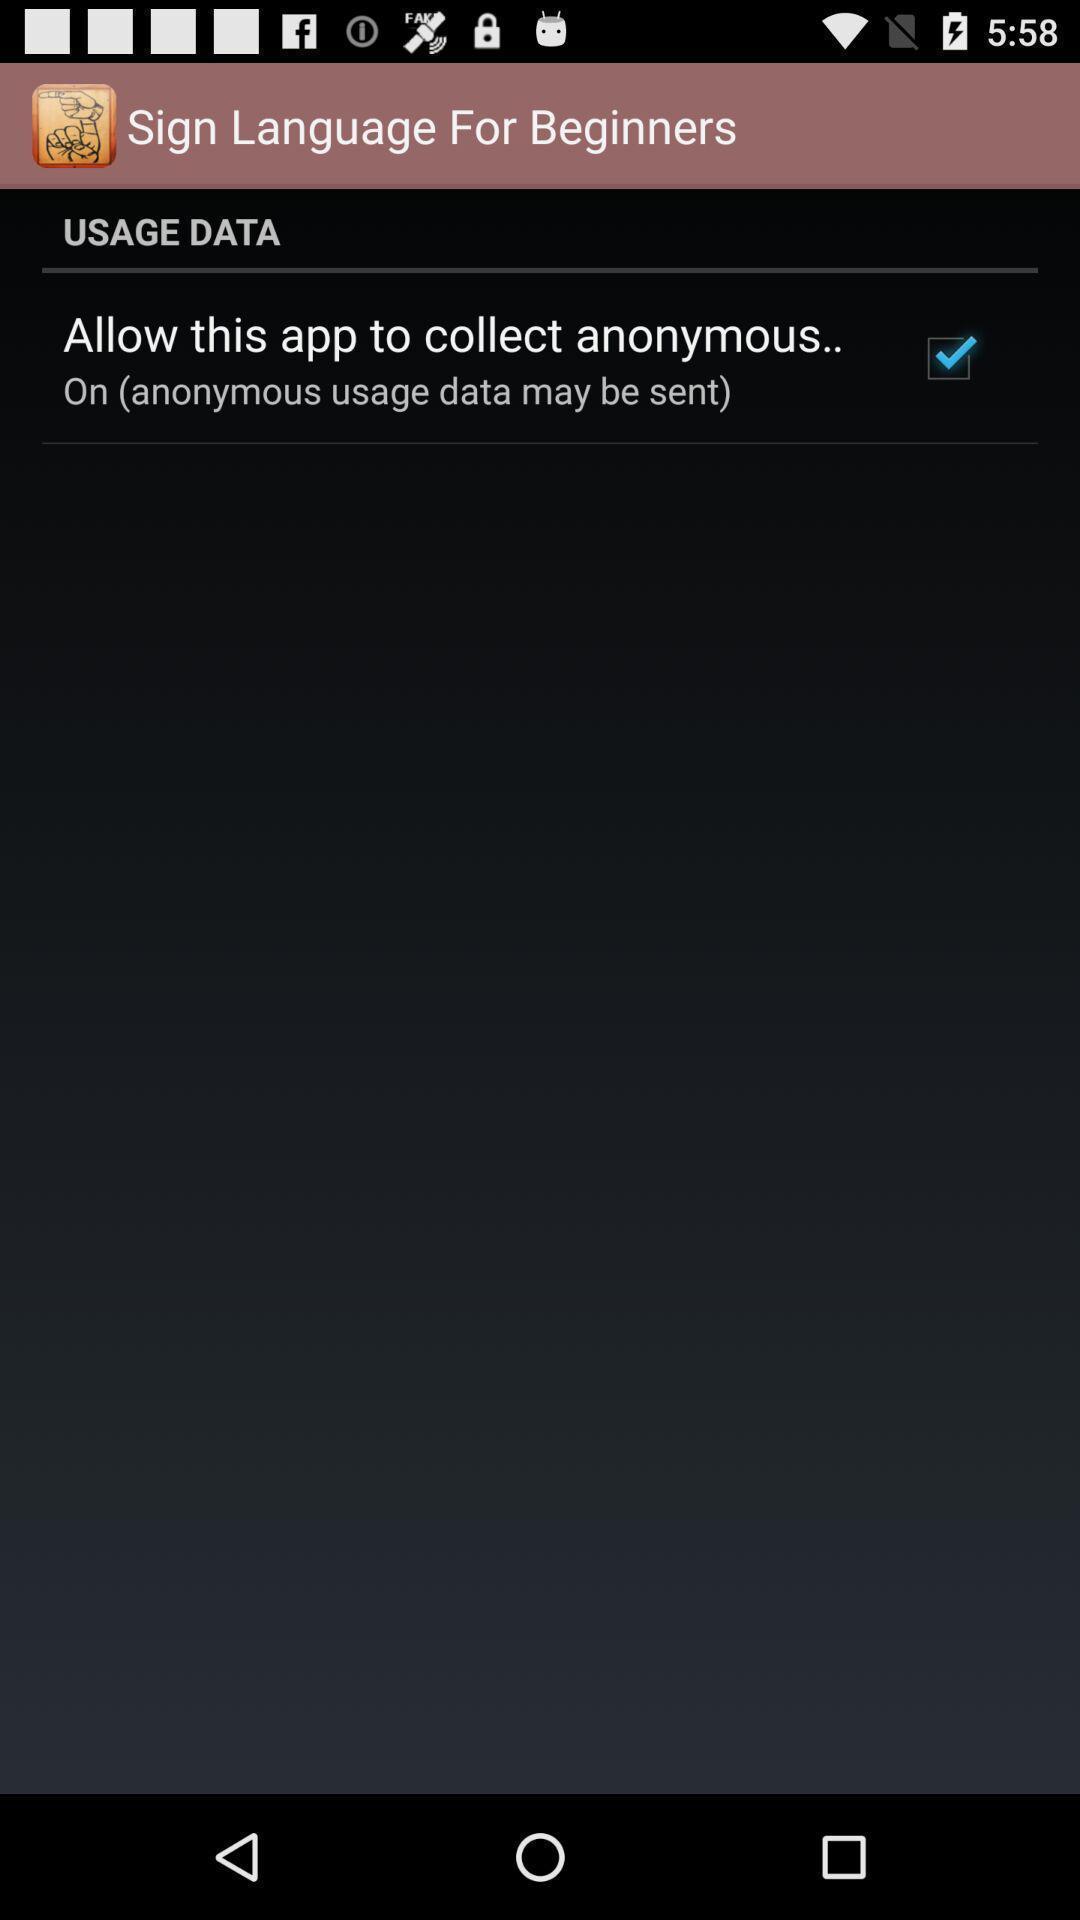What is the overall content of this screenshot? Starting page of a learning app. 